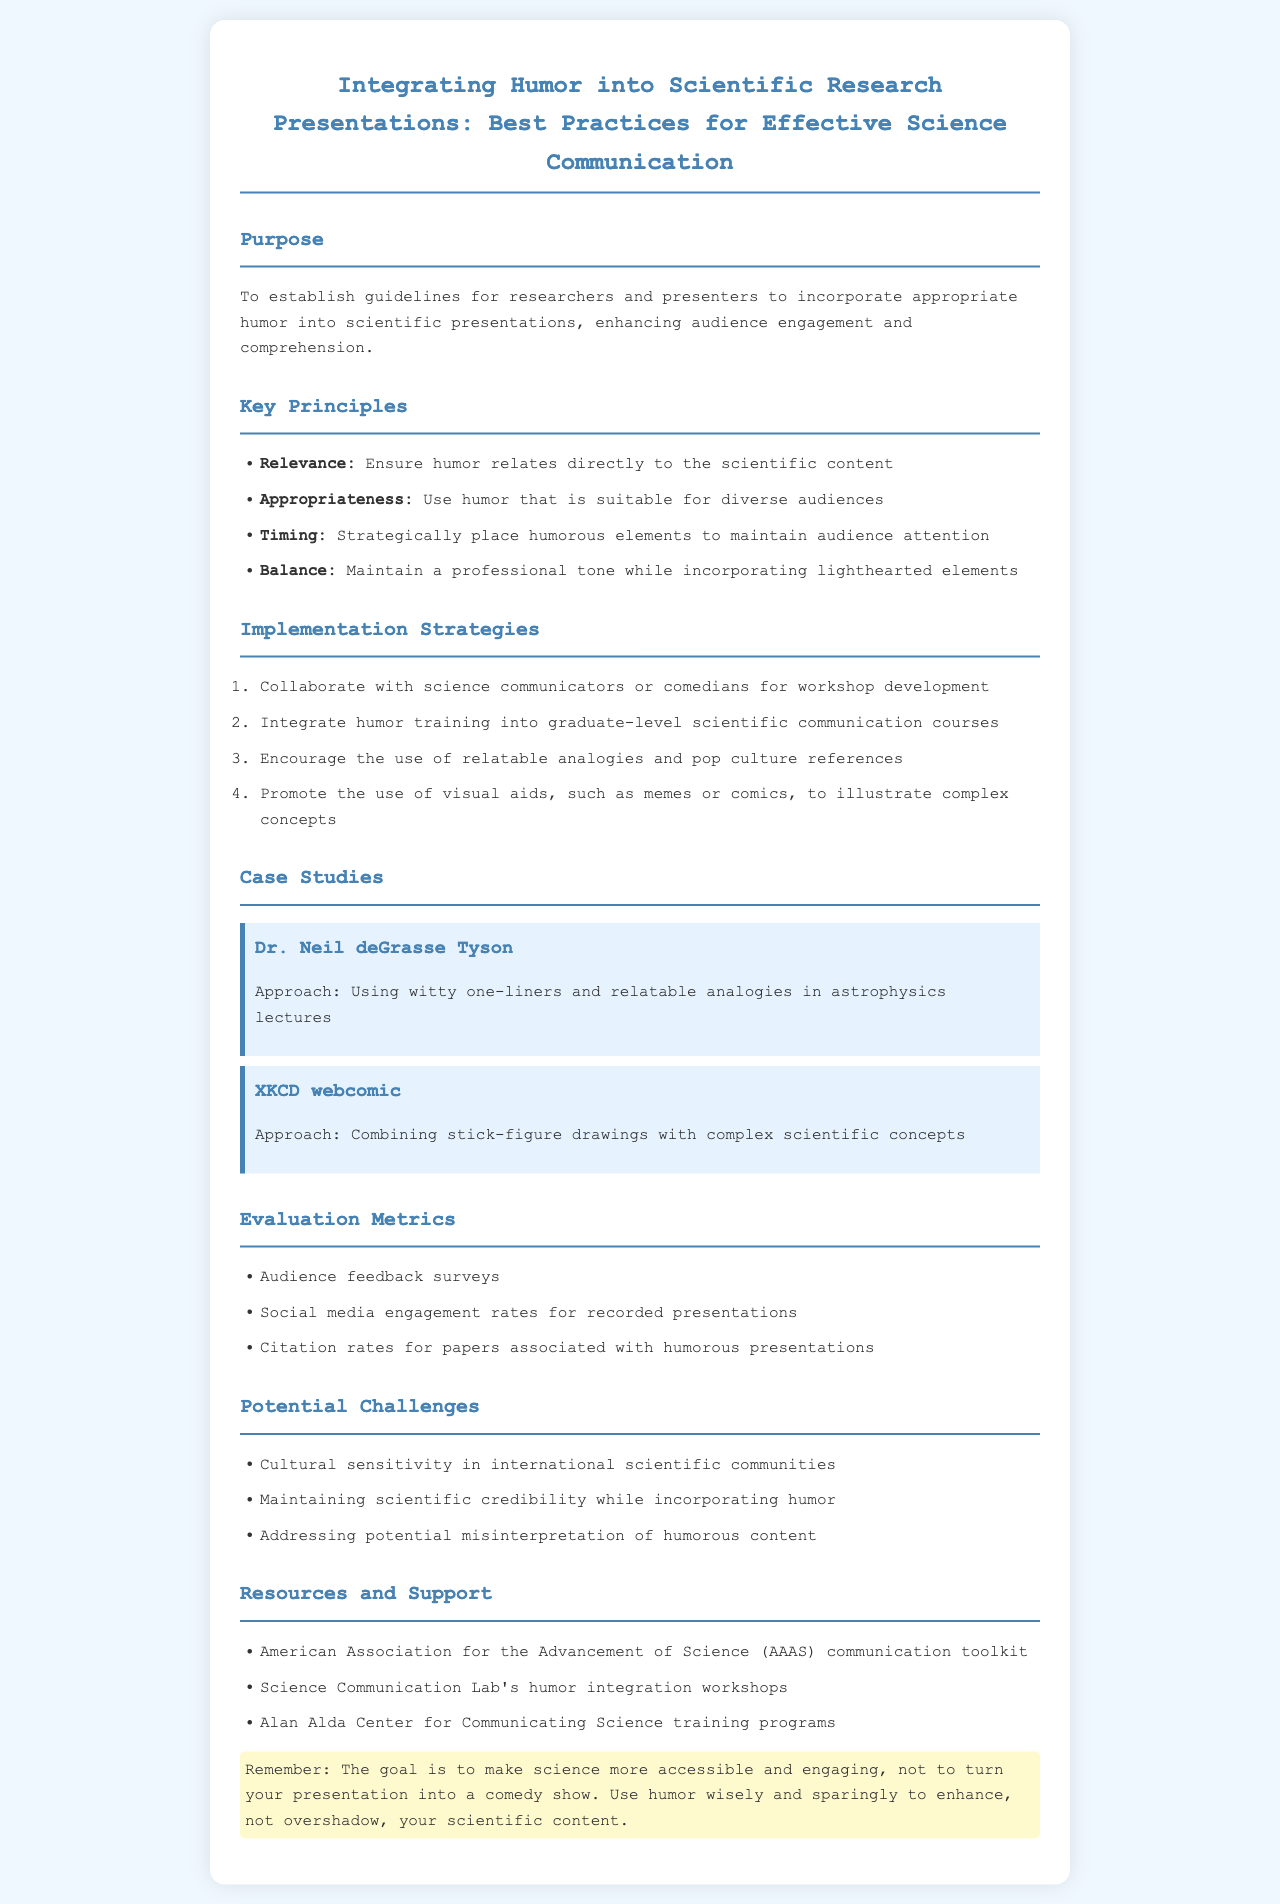What is the purpose of the policy? The purpose is to establish guidelines for researchers and presenters to incorporate appropriate humor into scientific presentations, enhancing audience engagement and comprehension.
Answer: To establish guidelines for researchers and presenters to incorporate appropriate humor into scientific presentations What is one of the key principles for integrating humor? One of the key principles is ensuring that humor relates directly to the scientific content.
Answer: Relevance How many case studies are included in the document? The document lists two case studies related to known figures or works in science communication.
Answer: 2 What is one implementation strategy mentioned? The document suggests integrating humor training into graduate-level scientific communication courses as a strategy.
Answer: Integrate humor training into graduate-level scientific communication courses What is a potential challenge regarding humor in international settings? One challenge highlighted is cultural sensitivity in international scientific communities.
Answer: Cultural sensitivity What type of feedback is used to evaluate humorous presentations? Audience feedback surveys are specified as one of the evaluation metrics.
Answer: Audience feedback surveys Which organization provides a communication toolkit as a resource? The American Association for the Advancement of Science is noted for providing resources and support in this area.
Answer: American Association for the Advancement of Science What approach does Dr. Neil deGrasse Tyson use in his lectures? Dr. Neil deGrasse Tyson is noted for using witty one-liners and relatable analogies in his lectures.
Answer: Using witty one-liners and relatable analogies What should the goal of using humor in science communication be? The goal is to make science more accessible and engaging, not to turn the presentation into a comedy show.
Answer: Make science more accessible and engaging 